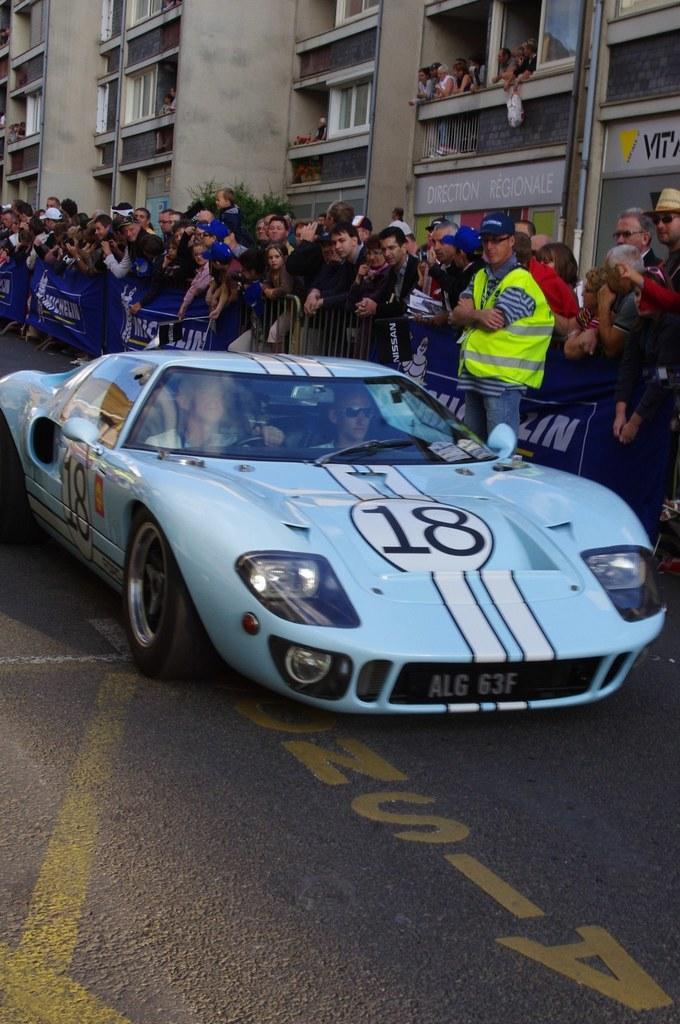Can you describe this image briefly? This picture shows a blue car and we say few people are standing and watching. Few of them wore caps on their heads and we see a building and a tree and we see few people watching from the windows of the building. 